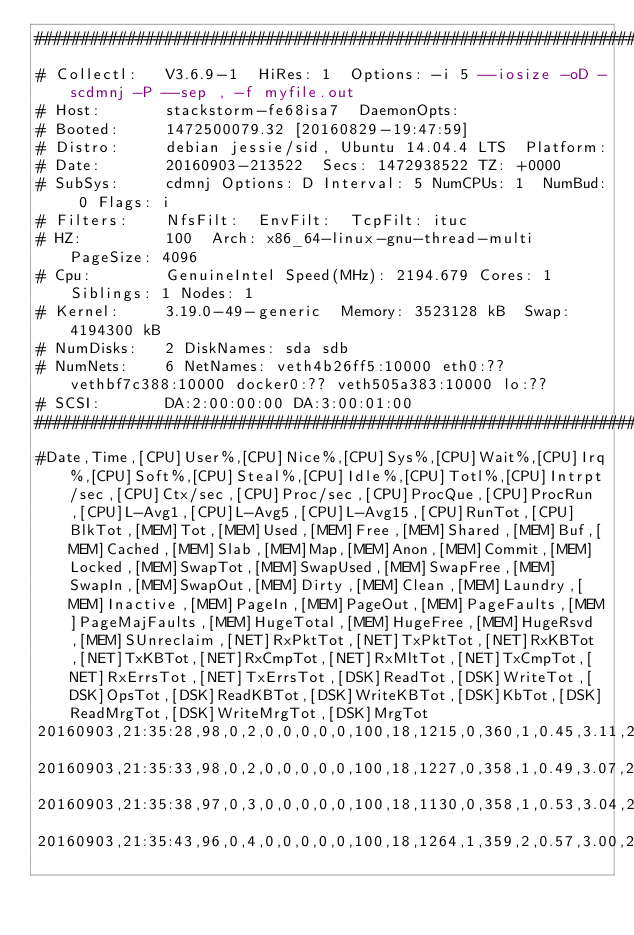<code> <loc_0><loc_0><loc_500><loc_500><_SQL_>################################################################################
# Collectl:   V3.6.9-1  HiRes: 1  Options: -i 5 --iosize -oD -scdmnj -P --sep , -f myfile.out 
# Host:       stackstorm-fe68isa7  DaemonOpts: 
# Booted:     1472500079.32 [20160829-19:47:59]
# Distro:     debian jessie/sid, Ubuntu 14.04.4 LTS  Platform: 
# Date:       20160903-213522  Secs: 1472938522 TZ: +0000
# SubSys:     cdmnj Options: D Interval: 5 NumCPUs: 1  NumBud: 0 Flags: i
# Filters:    NfsFilt:  EnvFilt:  TcpFilt: ituc
# HZ:         100  Arch: x86_64-linux-gnu-thread-multi PageSize: 4096
# Cpu:        GenuineIntel Speed(MHz): 2194.679 Cores: 1  Siblings: 1 Nodes: 1
# Kernel:     3.19.0-49-generic  Memory: 3523128 kB  Swap: 4194300 kB
# NumDisks:   2 DiskNames: sda sdb
# NumNets:    6 NetNames: veth4b26ff5:10000 eth0:?? vethbf7c388:10000 docker0:?? veth505a383:10000 lo:??
# SCSI:       DA:2:00:00:00 DA:3:00:01:00
################################################################################
#Date,Time,[CPU]User%,[CPU]Nice%,[CPU]Sys%,[CPU]Wait%,[CPU]Irq%,[CPU]Soft%,[CPU]Steal%,[CPU]Idle%,[CPU]Totl%,[CPU]Intrpt/sec,[CPU]Ctx/sec,[CPU]Proc/sec,[CPU]ProcQue,[CPU]ProcRun,[CPU]L-Avg1,[CPU]L-Avg5,[CPU]L-Avg15,[CPU]RunTot,[CPU]BlkTot,[MEM]Tot,[MEM]Used,[MEM]Free,[MEM]Shared,[MEM]Buf,[MEM]Cached,[MEM]Slab,[MEM]Map,[MEM]Anon,[MEM]Commit,[MEM]Locked,[MEM]SwapTot,[MEM]SwapUsed,[MEM]SwapFree,[MEM]SwapIn,[MEM]SwapOut,[MEM]Dirty,[MEM]Clean,[MEM]Laundry,[MEM]Inactive,[MEM]PageIn,[MEM]PageOut,[MEM]PageFaults,[MEM]PageMajFaults,[MEM]HugeTotal,[MEM]HugeFree,[MEM]HugeRsvd,[MEM]SUnreclaim,[NET]RxPktTot,[NET]TxPktTot,[NET]RxKBTot,[NET]TxKBTot,[NET]RxCmpTot,[NET]RxMltTot,[NET]TxCmpTot,[NET]RxErrsTot,[NET]TxErrsTot,[DSK]ReadTot,[DSK]WriteTot,[DSK]OpsTot,[DSK]ReadKBTot,[DSK]WriteKBTot,[DSK]KbTot,[DSK]ReadMrgTot,[DSK]WriteMrgTot,[DSK]MrgTot
20160903,21:35:28,98,0,2,0,0,0,0,0,100,18,1215,0,360,1,0.45,3.11,2.34,1,0,3523128,743688,2779440,0,9164,82644,54276,48896,374544,2297440,0,4194300,1047584,3146716,0,0,2224,0,0,38272,0,34,289,0,0,0,0,26284,7,12,1,4,0,0,0,0,0,0,2,2,0,34,34,0,5,5
20160903,21:35:33,98,0,2,0,0,0,0,0,100,18,1227,0,358,1,0.49,3.07,2.33,1,0,3523128,742280,2780848,0,9172,82656,54308,47052,373316,2297440,0,4194300,1047584,3146716,0,0,2384,0,0,38272,2,153,173,0,0,0,0,26316,8,13,1,4,0,0,0,0,0,0,28,29,2,160,161,0,7,7
20160903,21:35:38,97,0,3,0,0,0,0,0,100,18,1130,0,358,1,0.53,3.04,2.32,1,0,3523128,742404,2780724,0,9180,82672,54308,47052,373328,2297440,0,4194300,1047584,3146716,0,0,3064,0,0,38268,0,22,211,0,0,0,0,26316,7,11,1,3,0,0,0,0,0,0,2,2,0,23,23,0,4,4
20160903,21:35:43,96,0,4,0,0,0,0,0,100,18,1264,1,359,2,0.57,3.00,2.32,2,0,3523128,742048,2781080,0,9196,82692,54308,47040,373356,2297440,0,4194300,1047584,3146716,0,0,2808,0,0,38232,0,97,266,0,0,0,0,26316,12,18,3,5,0,0,0,0,0,0,16,16,0,99,99,0,6,6</code> 